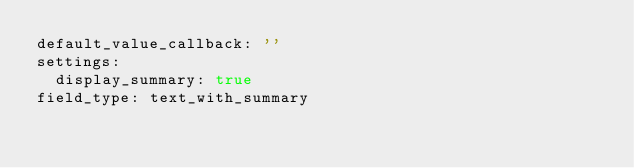Convert code to text. <code><loc_0><loc_0><loc_500><loc_500><_YAML_>default_value_callback: ''
settings:
  display_summary: true
field_type: text_with_summary
</code> 